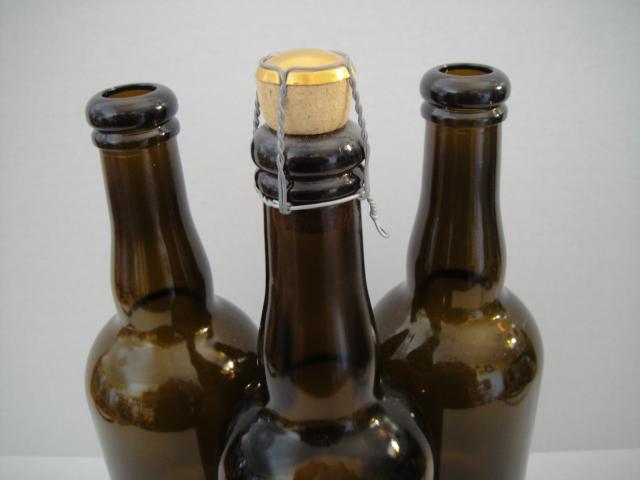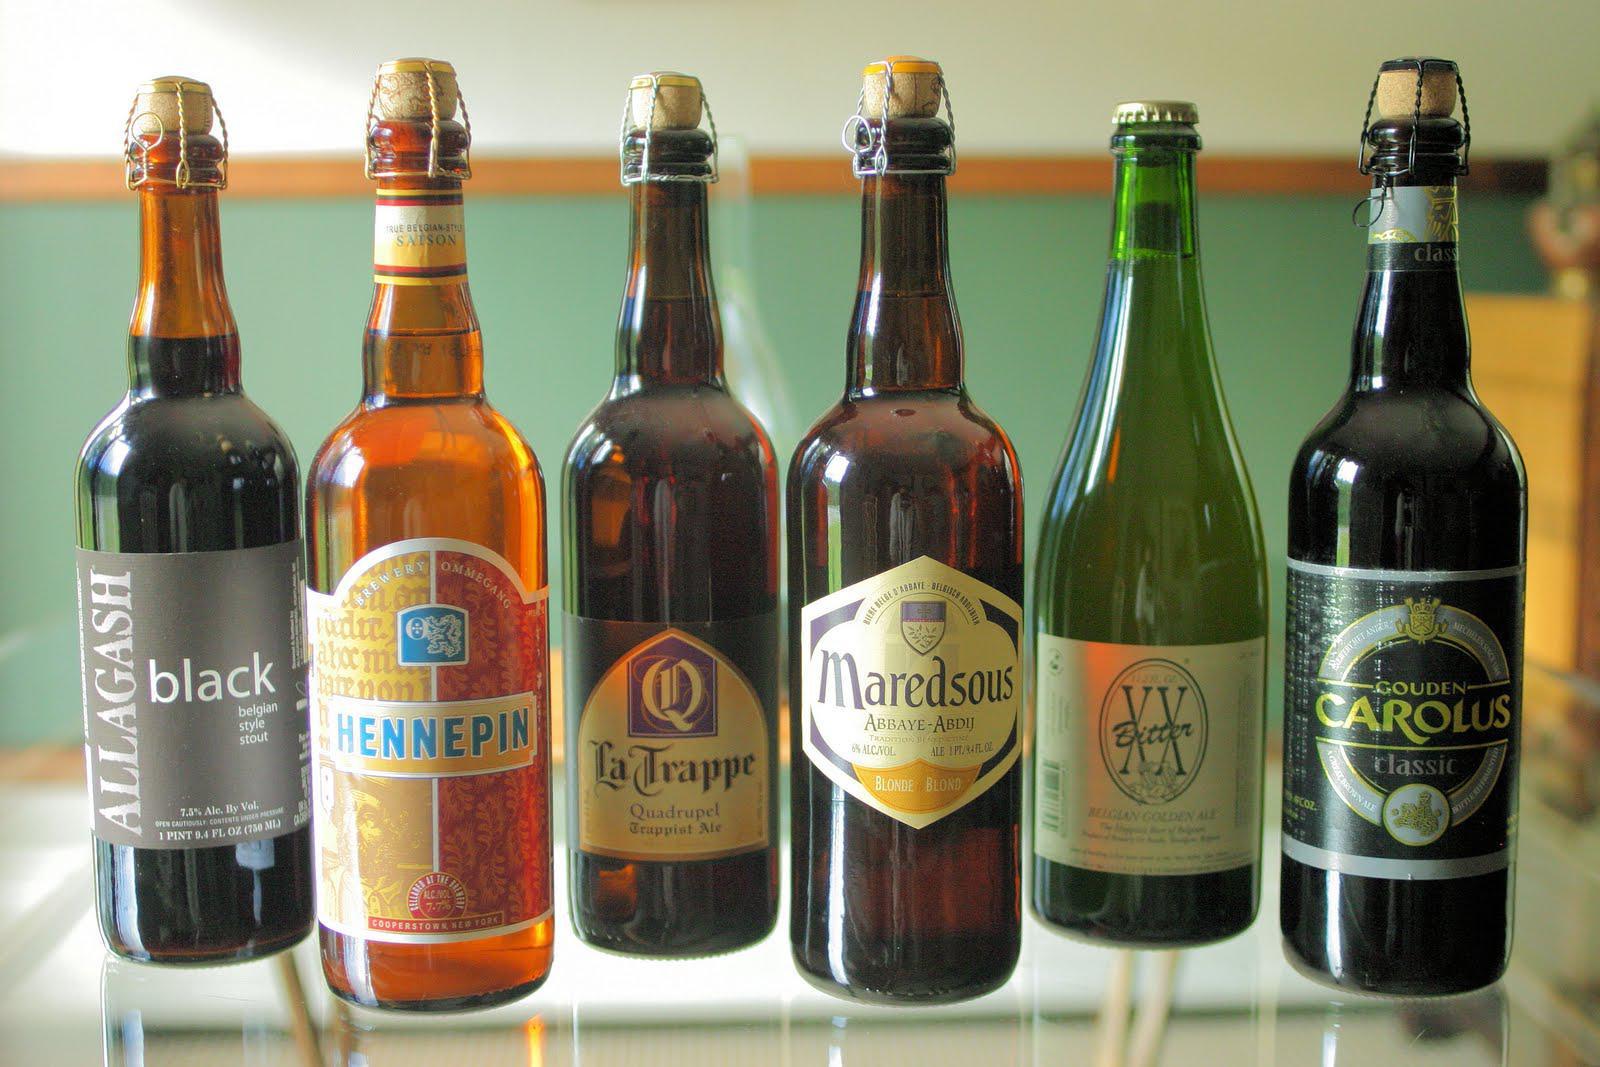The first image is the image on the left, the second image is the image on the right. Given the left and right images, does the statement "There are more bottles in the image on the right." hold true? Answer yes or no. Yes. The first image is the image on the left, the second image is the image on the right. Assess this claim about the two images: "There is only one bottle in at least one of the images.". Correct or not? Answer yes or no. No. 